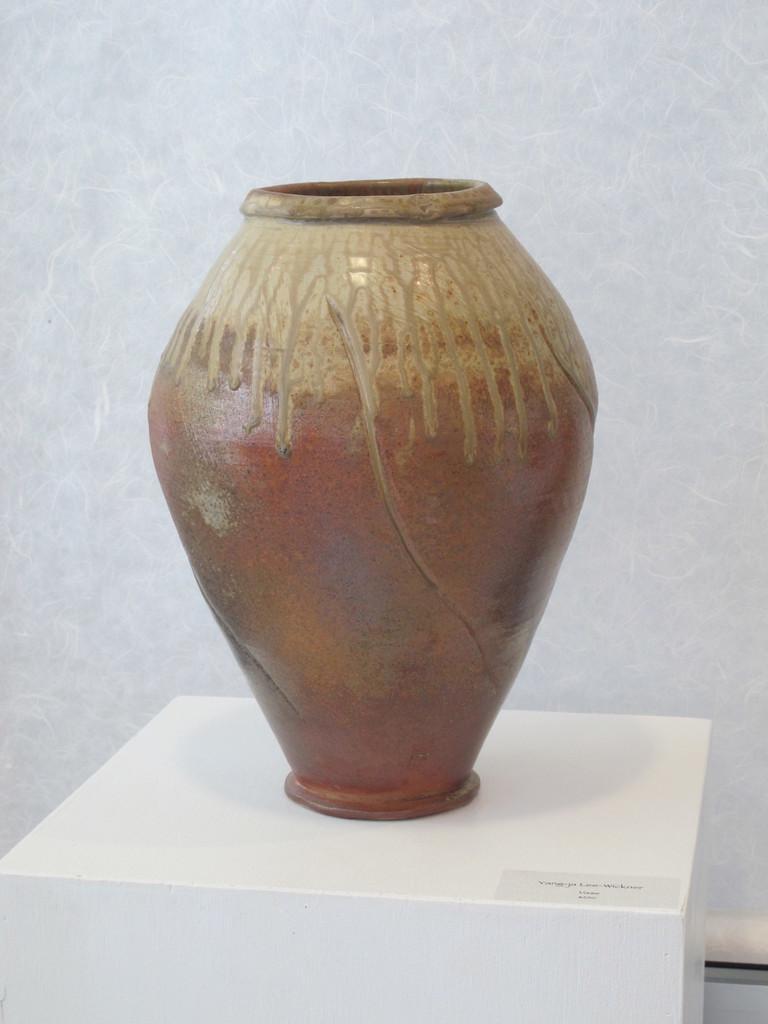Please provide a concise description of this image. In this picture we can see a table at the bottom, there is a ceramic pot present on the table, in the background there is a wall. 